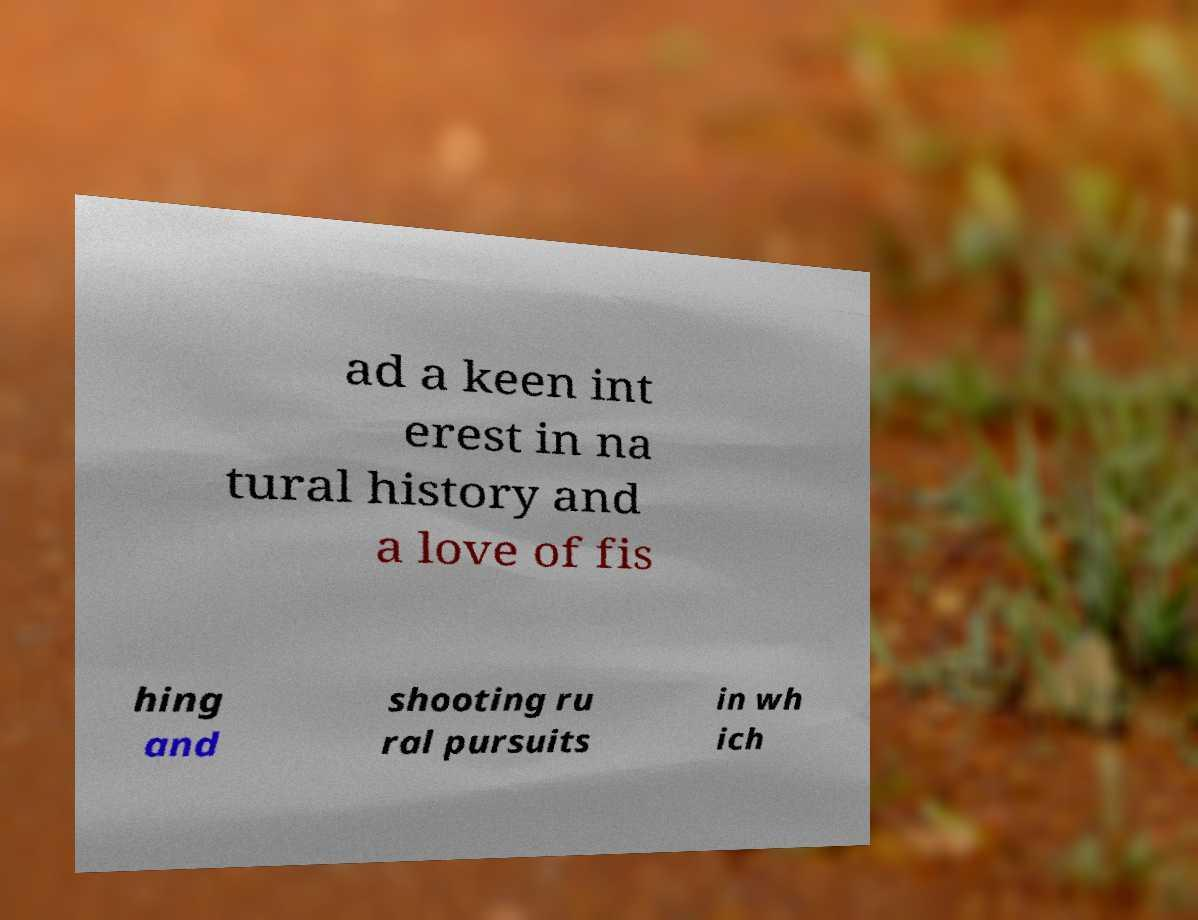Can you read and provide the text displayed in the image?This photo seems to have some interesting text. Can you extract and type it out for me? ad a keen int erest in na tural history and a love of fis hing and shooting ru ral pursuits in wh ich 